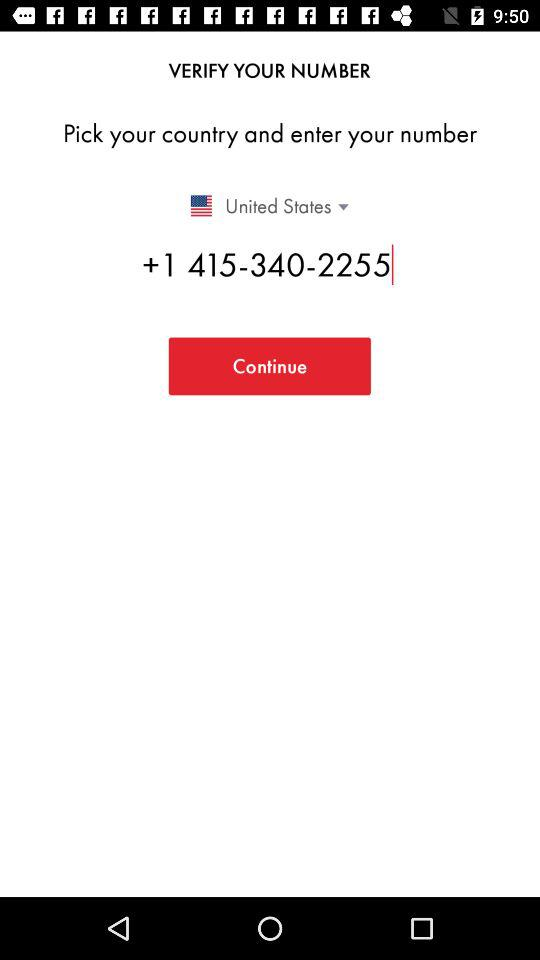Which country's contact number is entered? The country is the United States. 